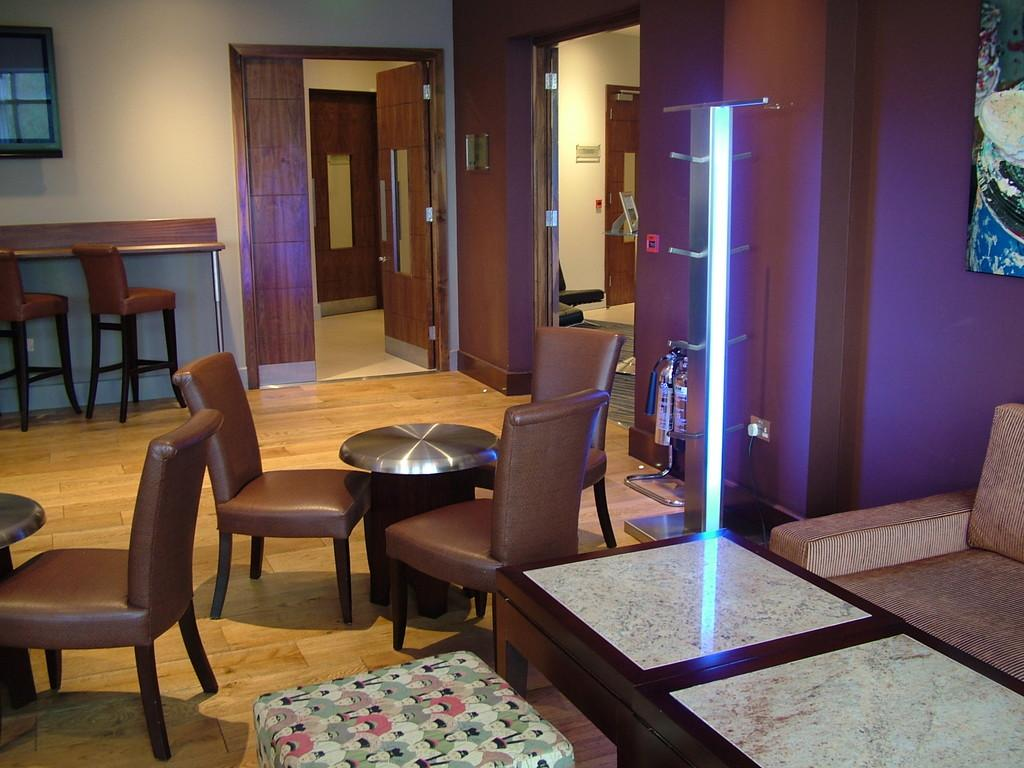What type of furniture is in the room? There is a sofa, chairs, and tables in the room. Where is the table located in the room? There is a table to the right side of the room. What is on the left side of the room? There are chairs and tables on the left side of the room. How many doors are in the room? There are two doors in the room. What is used for illumination in the room? There is a light in the room. What type of scarf is draped over the sofa in the image? There is no scarf present in the image; it only shows a sofa, chairs, tables, doors, and a light. What type of loaf is sitting on the table in the image? There is no loaf present in the image; it only shows a table with other objects. 